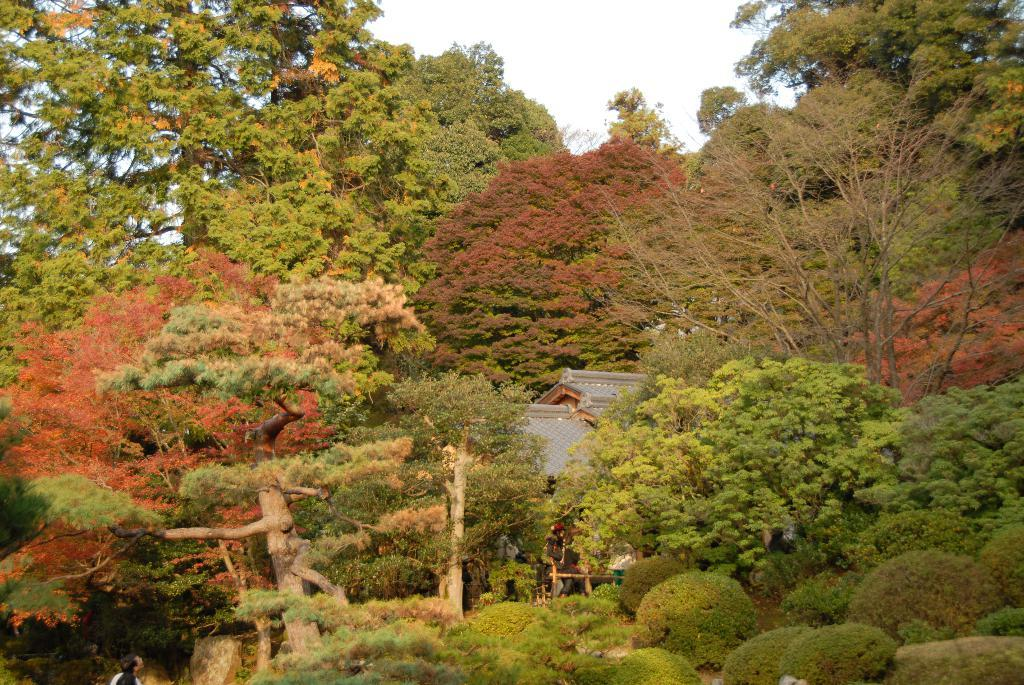What type of natural elements can be seen in the image? There are trees in the image. What type of structure is present in the image? There is a house in the image. Are there any people visible in the image? Yes, there is a person in the image. What can be seen in the background of the image? The sky is visible in the background of the image. What type of writing can be seen on the trees in the image? There is no writing present on the trees in the image. How does the person in the image express their hate towards the house? There is no indication of hate or any negative emotion towards the house in the image. 